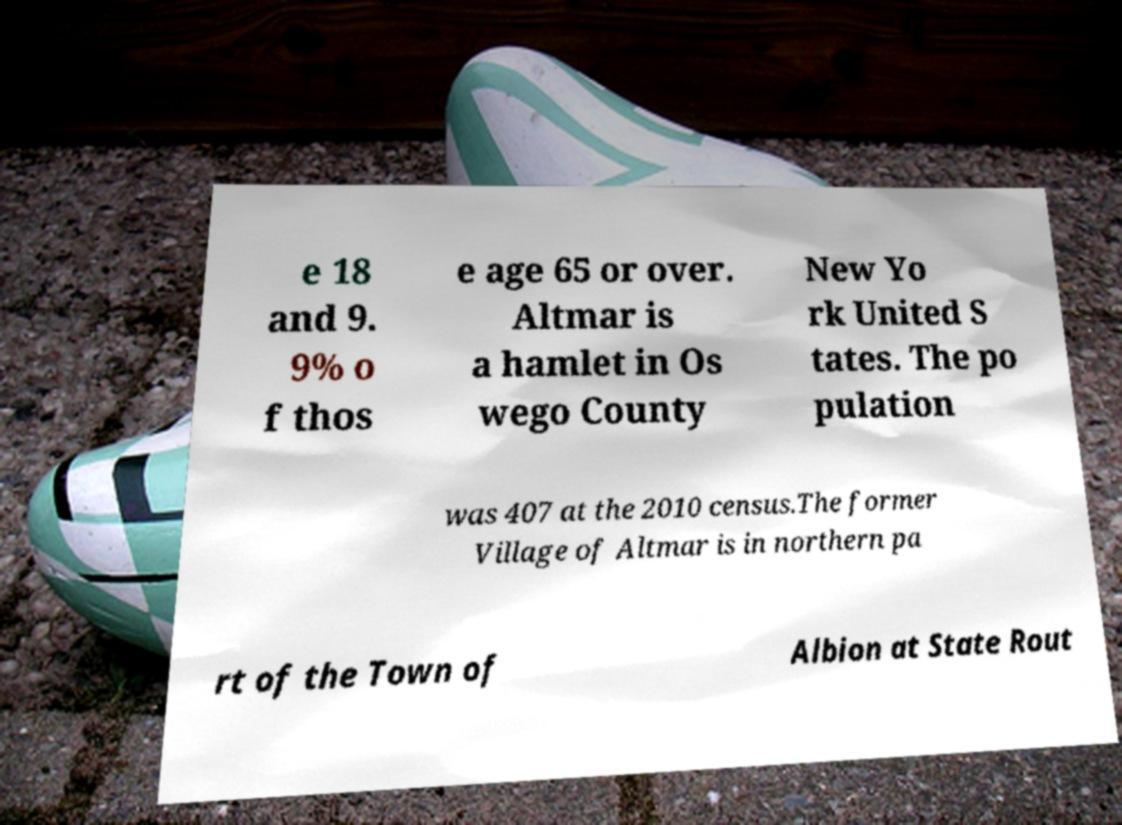There's text embedded in this image that I need extracted. Can you transcribe it verbatim? e 18 and 9. 9% o f thos e age 65 or over. Altmar is a hamlet in Os wego County New Yo rk United S tates. The po pulation was 407 at the 2010 census.The former Village of Altmar is in northern pa rt of the Town of Albion at State Rout 